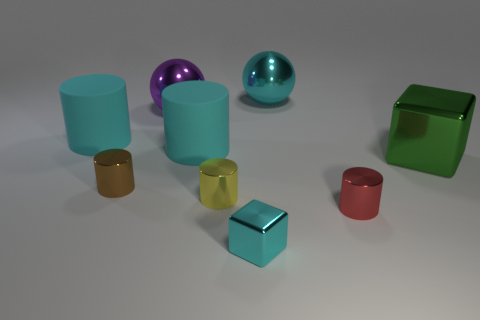What color is the other thing that is the same shape as the green shiny object?
Keep it short and to the point. Cyan. What number of other shiny things have the same shape as the purple metallic thing?
Ensure brevity in your answer.  1. There is a big sphere that is the same color as the small metal block; what material is it?
Your response must be concise. Metal. What number of brown cylinders are there?
Keep it short and to the point. 1. Is there a tiny gray cylinder that has the same material as the yellow cylinder?
Offer a terse response. No. There is a metal thing that is the same color as the small shiny cube; what size is it?
Offer a terse response. Large. Is the size of the matte object on the left side of the purple metallic sphere the same as the matte thing on the right side of the small brown object?
Offer a terse response. Yes. There is a yellow metallic cylinder in front of the big cyan metallic thing; what size is it?
Ensure brevity in your answer.  Small. Is there a large shiny cube of the same color as the tiny cube?
Keep it short and to the point. No. Is there a tiny brown metallic cylinder to the right of the shiny block that is to the left of the big green metal object?
Give a very brief answer. No. 